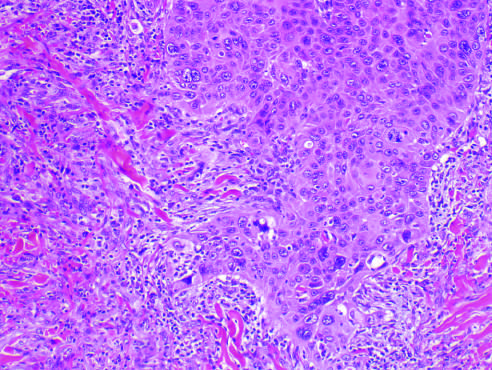does the tumor invade the dermal soft tissue as irregular projections of atypical squamous cells exhibiting acantholysis?
Answer the question using a single word or phrase. Yes 